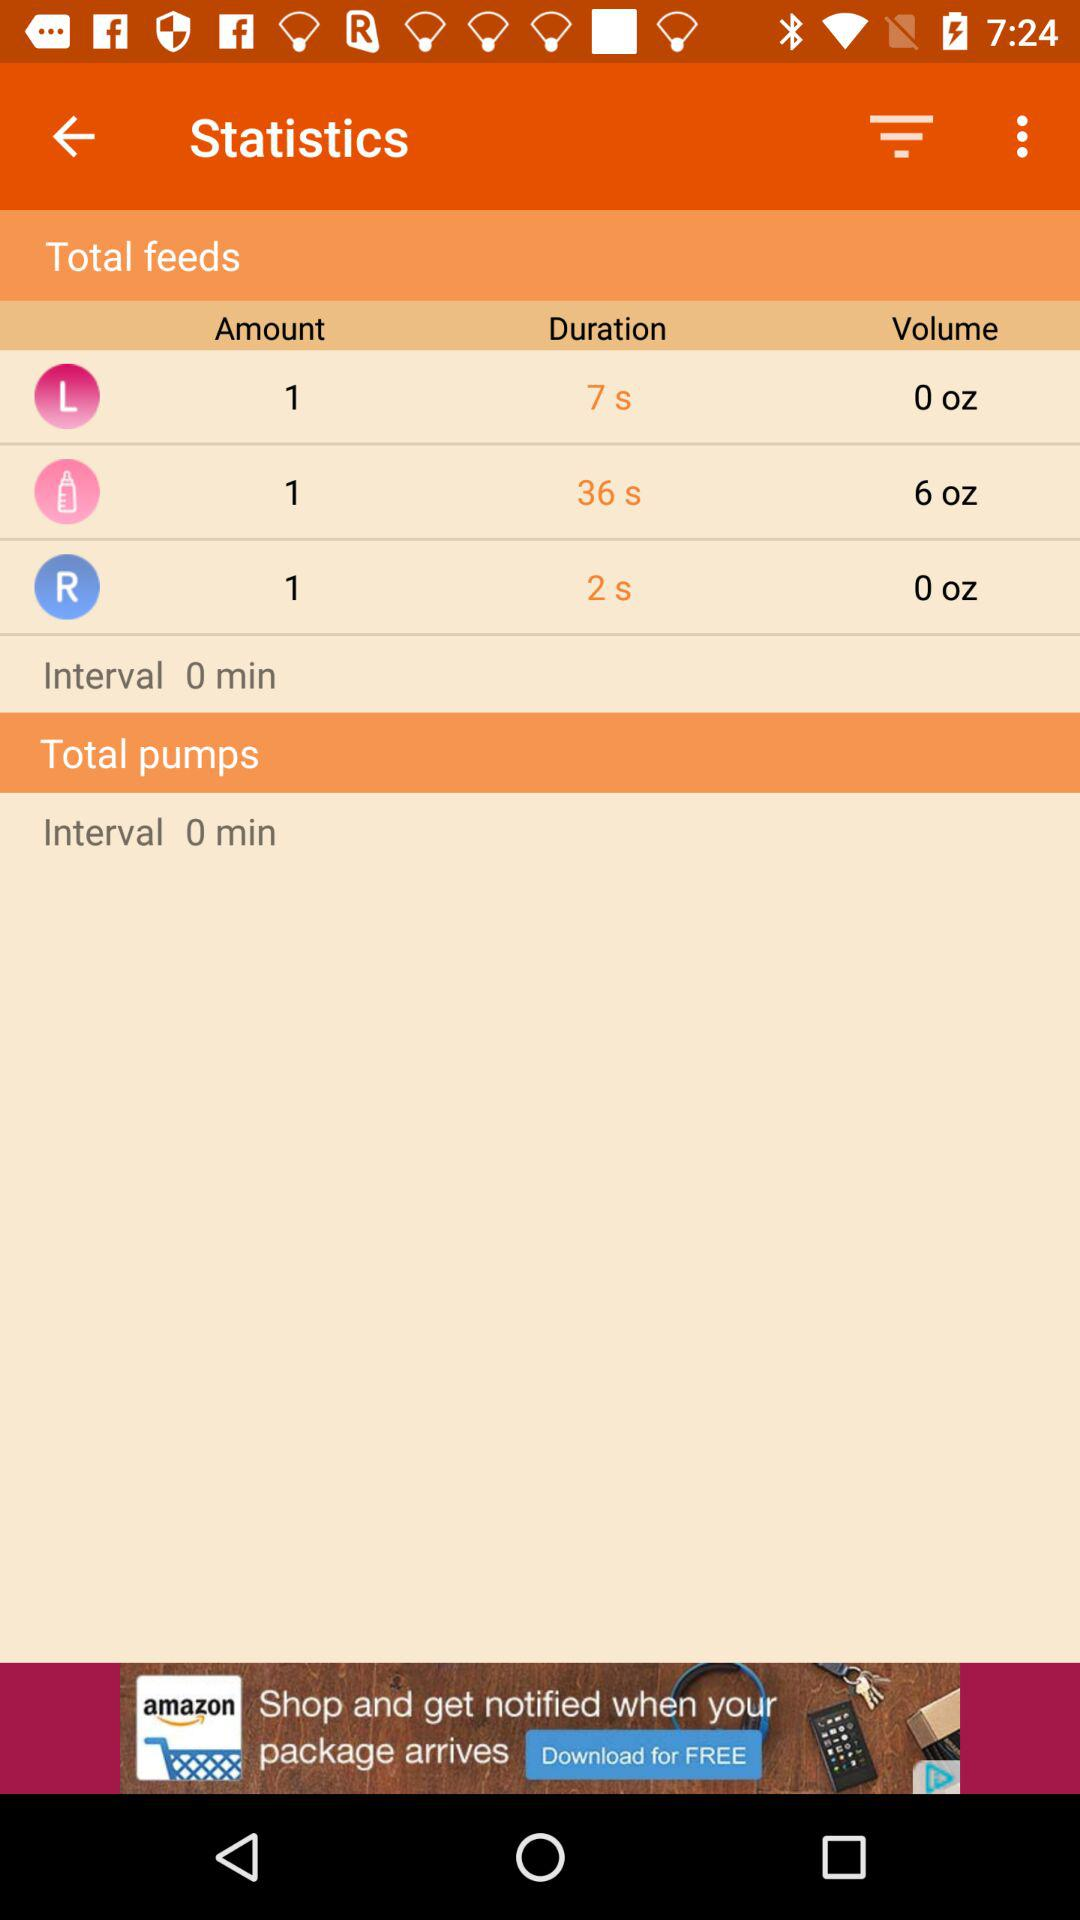What is the interval? The interval is 0 minutes. 